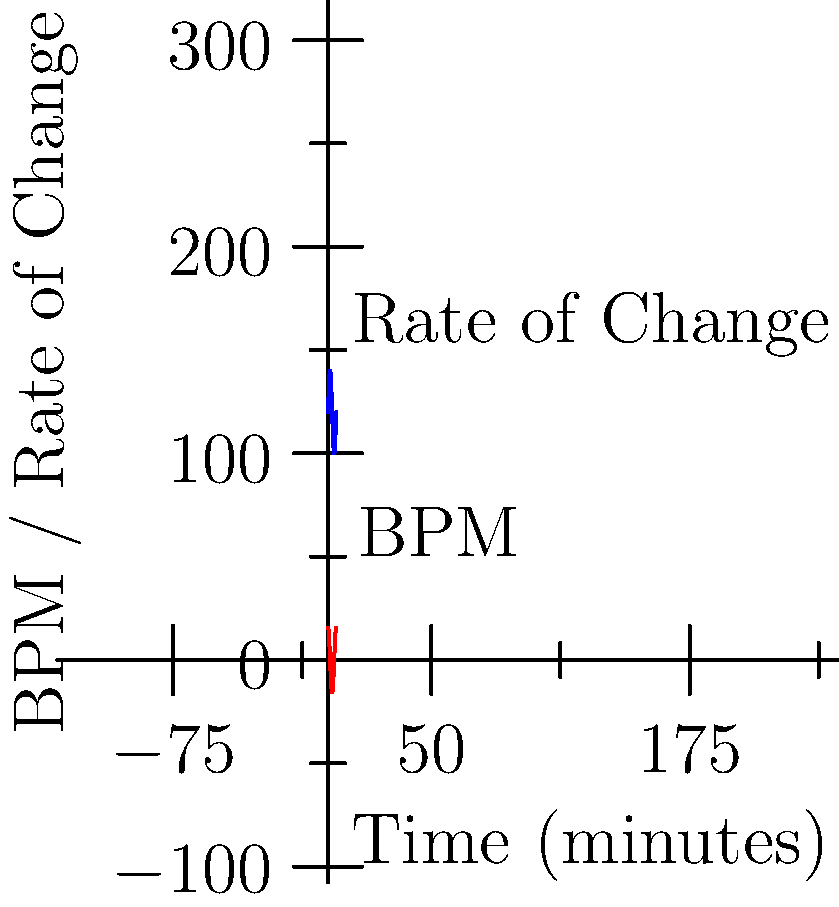As a DJ, you're experimenting with a new track that varies its tempo over time. The blue curve represents the beats per minute (BPM) of the track, while the red curve shows the rate of change of the tempo. At what time (in minutes) does the track reach its maximum tempo, and what is the corresponding rate of change at that moment? To solve this problem, we need to follow these steps:

1) The blue curve represents the BPM function, which appears to be sinusoidal:
   $$f(t) = 120 + 20\sin(\frac{\pi t}{2})$$
   where $t$ is time in minutes.

2) The maximum tempo occurs when $\sin(\frac{\pi t}{2}) = 1$, which happens when:
   $$\frac{\pi t}{2} = \frac{\pi}{2}$$
   $$t = 1$$

3) The red curve represents the derivative of the BPM function:
   $$f'(t) = 20 \cdot \frac{\pi}{4} \cos(\frac{\pi t}{2})$$

4) To find the rate of change at $t = 1$, we substitute this value:
   $$f'(1) = 20 \cdot \frac{\pi}{4} \cos(\frac{\pi}{2}) = 0$$

5) We can verify this graphically: at $t = 1$, the blue curve reaches its peak, and the red curve (rate of change) crosses the x-axis, indicating a rate of change of 0.
Answer: Maximum tempo at 1 minute; rate of change is 0 BPM/min 